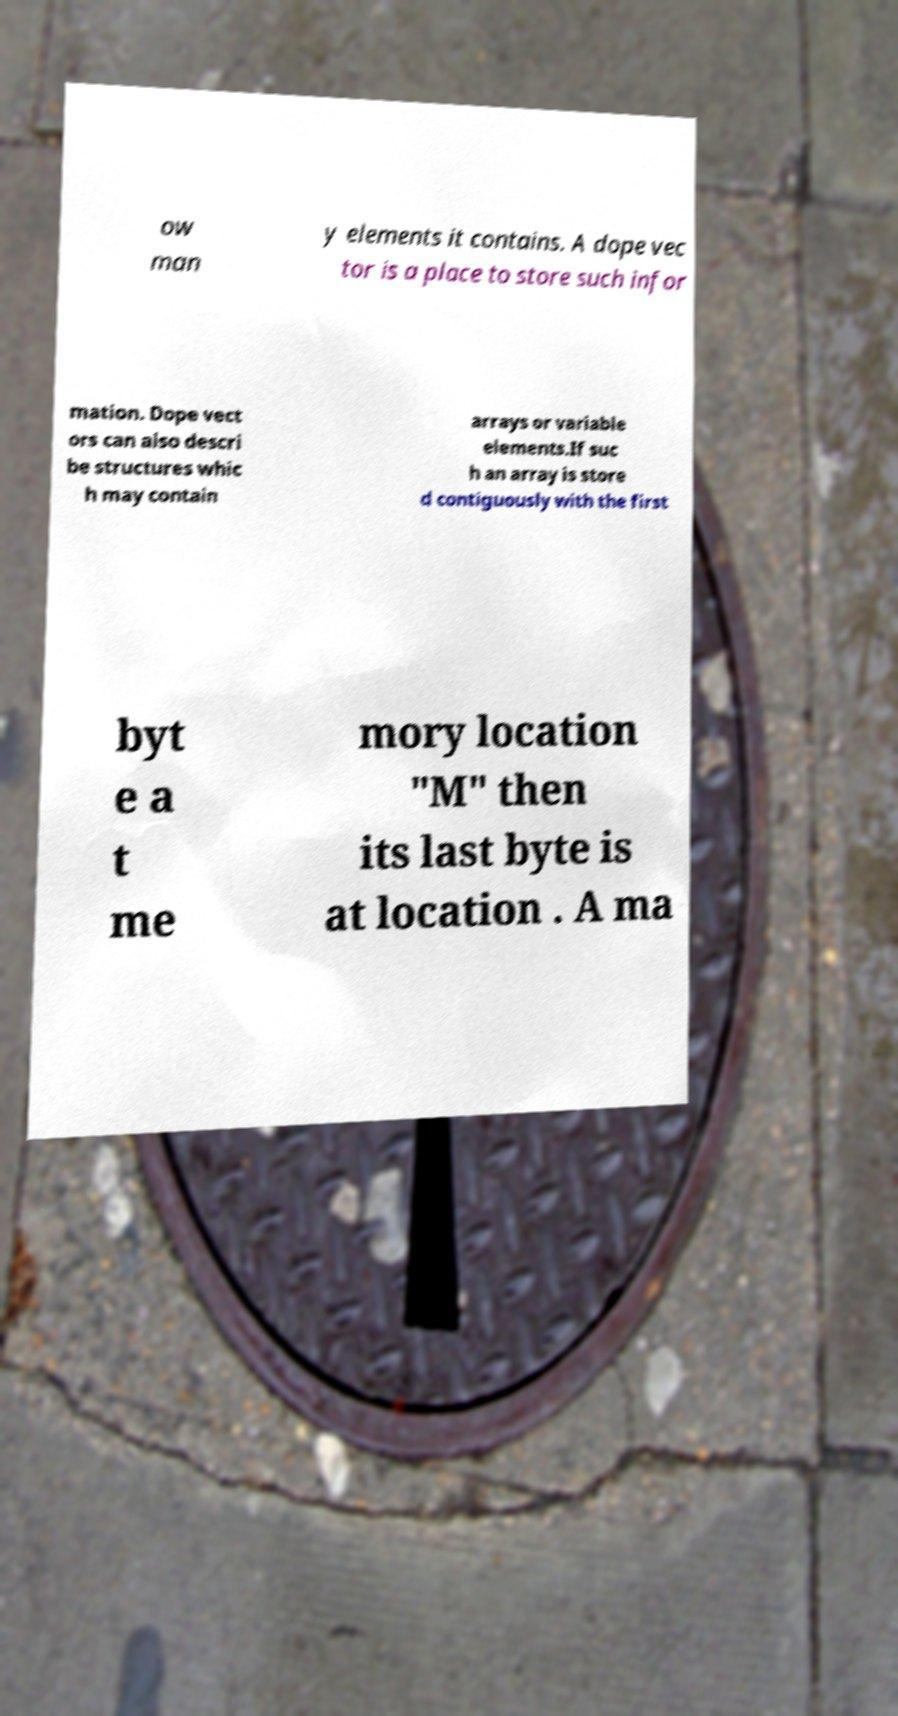For documentation purposes, I need the text within this image transcribed. Could you provide that? ow man y elements it contains. A dope vec tor is a place to store such infor mation. Dope vect ors can also descri be structures whic h may contain arrays or variable elements.If suc h an array is store d contiguously with the first byt e a t me mory location "M" then its last byte is at location . A ma 